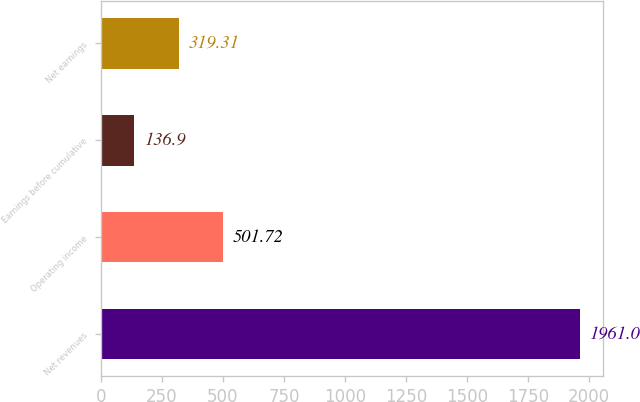Convert chart to OTSL. <chart><loc_0><loc_0><loc_500><loc_500><bar_chart><fcel>Net revenues<fcel>Operating income<fcel>Earnings before cumulative<fcel>Net earnings<nl><fcel>1961<fcel>501.72<fcel>136.9<fcel>319.31<nl></chart> 